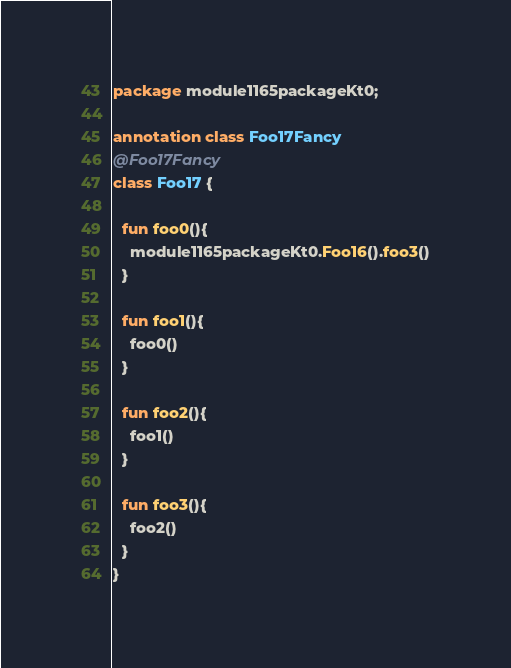<code> <loc_0><loc_0><loc_500><loc_500><_Kotlin_>package module1165packageKt0;

annotation class Foo17Fancy
@Foo17Fancy
class Foo17 {

  fun foo0(){
    module1165packageKt0.Foo16().foo3()
  }

  fun foo1(){
    foo0()
  }

  fun foo2(){
    foo1()
  }

  fun foo3(){
    foo2()
  }
}</code> 